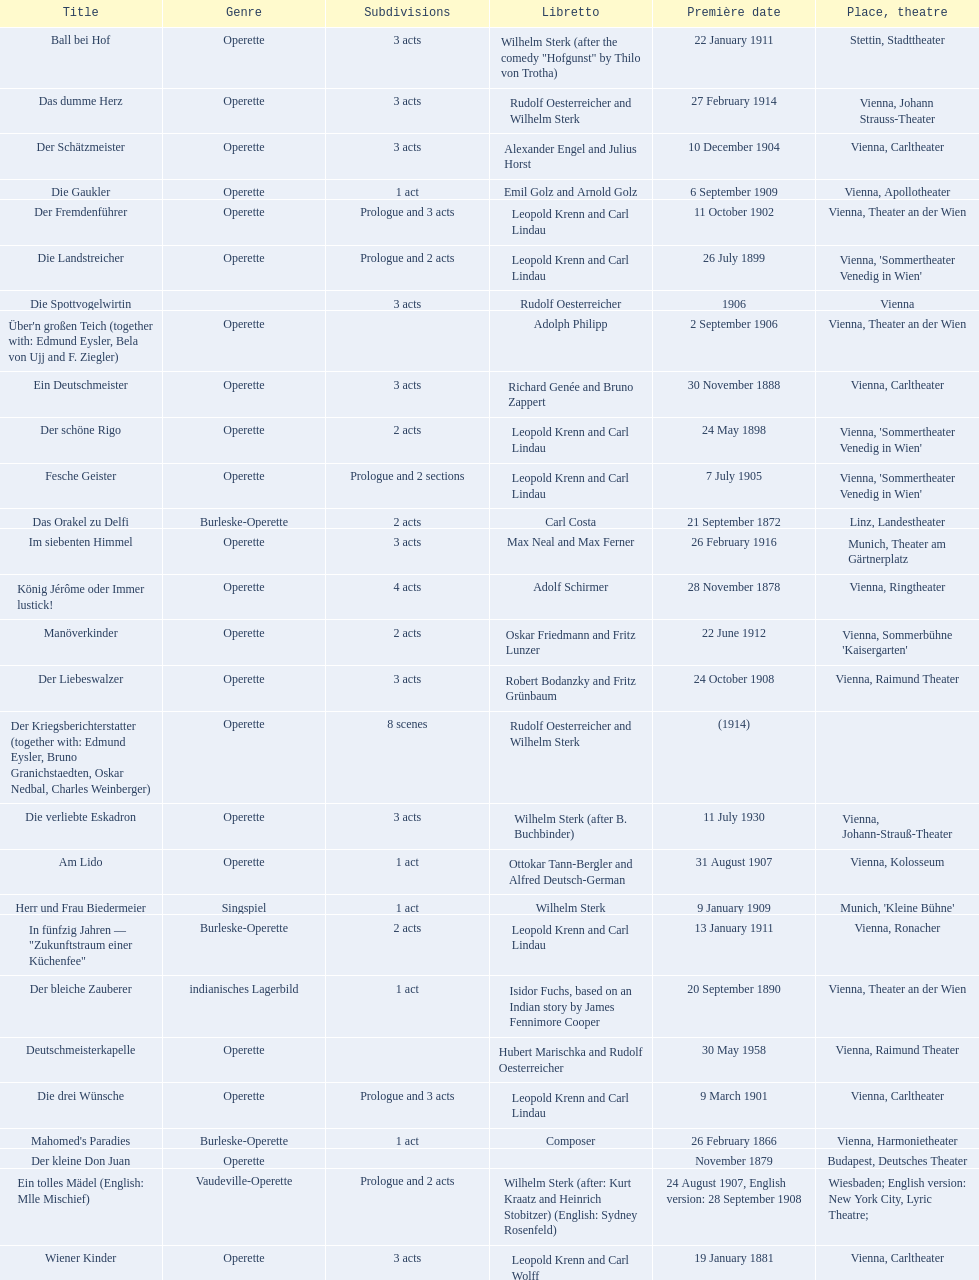How many of his operettas were 3 acts? 13. 